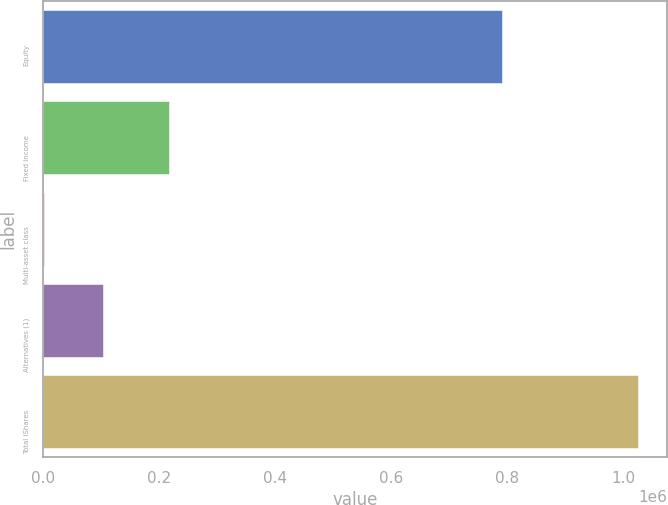<chart> <loc_0><loc_0><loc_500><loc_500><bar_chart><fcel>Equity<fcel>Fixed income<fcel>Multi-asset class<fcel>Alternatives (1)<fcel>Total iShares<nl><fcel>790067<fcel>217671<fcel>1773<fcel>104018<fcel>1.02423e+06<nl></chart> 